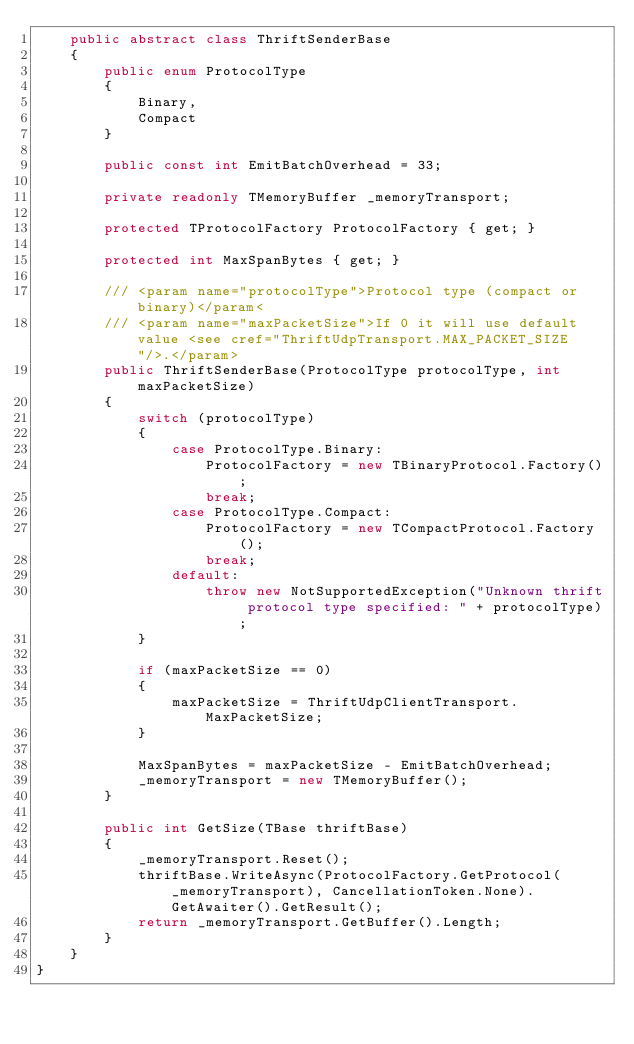<code> <loc_0><loc_0><loc_500><loc_500><_C#_>    public abstract class ThriftSenderBase
    {
        public enum ProtocolType
        {
            Binary,
            Compact
        }

        public const int EmitBatchOverhead = 33;

        private readonly TMemoryBuffer _memoryTransport;

        protected TProtocolFactory ProtocolFactory { get; }

        protected int MaxSpanBytes { get; }

        /// <param name="protocolType">Protocol type (compact or binary)</param<
        /// <param name="maxPacketSize">If 0 it will use default value <see cref="ThriftUdpTransport.MAX_PACKET_SIZE"/>.</param>
        public ThriftSenderBase(ProtocolType protocolType, int maxPacketSize)
        {
            switch (protocolType)
            {
                case ProtocolType.Binary:
                    ProtocolFactory = new TBinaryProtocol.Factory();
                    break;
                case ProtocolType.Compact:
                    ProtocolFactory = new TCompactProtocol.Factory();
                    break;
                default:
                    throw new NotSupportedException("Unknown thrift protocol type specified: " + protocolType);
            }

            if (maxPacketSize == 0)
            {
                maxPacketSize = ThriftUdpClientTransport.MaxPacketSize;
            }

            MaxSpanBytes = maxPacketSize - EmitBatchOverhead;
            _memoryTransport = new TMemoryBuffer();
        }

        public int GetSize(TBase thriftBase)
        {
            _memoryTransport.Reset();
            thriftBase.WriteAsync(ProtocolFactory.GetProtocol(_memoryTransport), CancellationToken.None).GetAwaiter().GetResult();
            return _memoryTransport.GetBuffer().Length;
        }
    }
}
</code> 